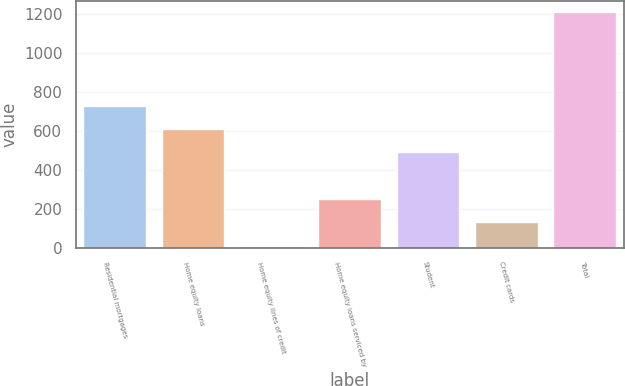Convert chart. <chart><loc_0><loc_0><loc_500><loc_500><bar_chart><fcel>Residential mortgages<fcel>Home equity loans<fcel>Home equity lines of credit<fcel>Home equity loans serviced by<fcel>Student<fcel>Credit cards<fcel>Total<nl><fcel>729.2<fcel>609.5<fcel>11<fcel>250.4<fcel>489.8<fcel>130.7<fcel>1208<nl></chart> 